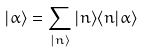Convert formula to latex. <formula><loc_0><loc_0><loc_500><loc_500>| \alpha \rangle = \sum _ { | n \rangle } | n \rangle \langle n | \alpha \rangle</formula> 